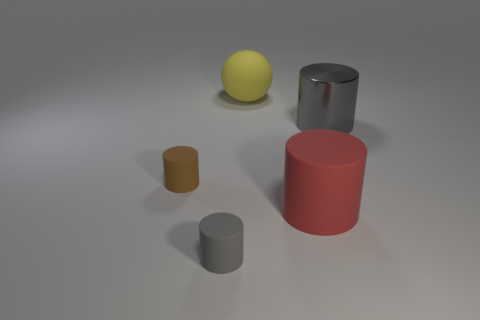Is there anything else that is the same material as the sphere?
Your answer should be compact. Yes. What color is the tiny thing to the right of the brown rubber cylinder?
Give a very brief answer. Gray. How many things are gray things that are behind the brown matte cylinder or shiny cylinders in front of the big yellow ball?
Your answer should be very brief. 1. How many other large rubber things have the same shape as the brown thing?
Offer a terse response. 1. There is another rubber cylinder that is the same size as the gray rubber cylinder; what color is it?
Give a very brief answer. Brown. There is a tiny matte thing that is in front of the tiny cylinder that is behind the small matte cylinder to the right of the small brown thing; what color is it?
Provide a short and direct response. Gray. There is a yellow matte ball; is it the same size as the gray object that is in front of the large metal cylinder?
Make the answer very short. No. How many objects are either big purple metallic things or rubber cylinders?
Provide a short and direct response. 3. Is there a tiny blue sphere made of the same material as the red thing?
Your answer should be very brief. No. The other cylinder that is the same color as the big metallic cylinder is what size?
Keep it short and to the point. Small. 